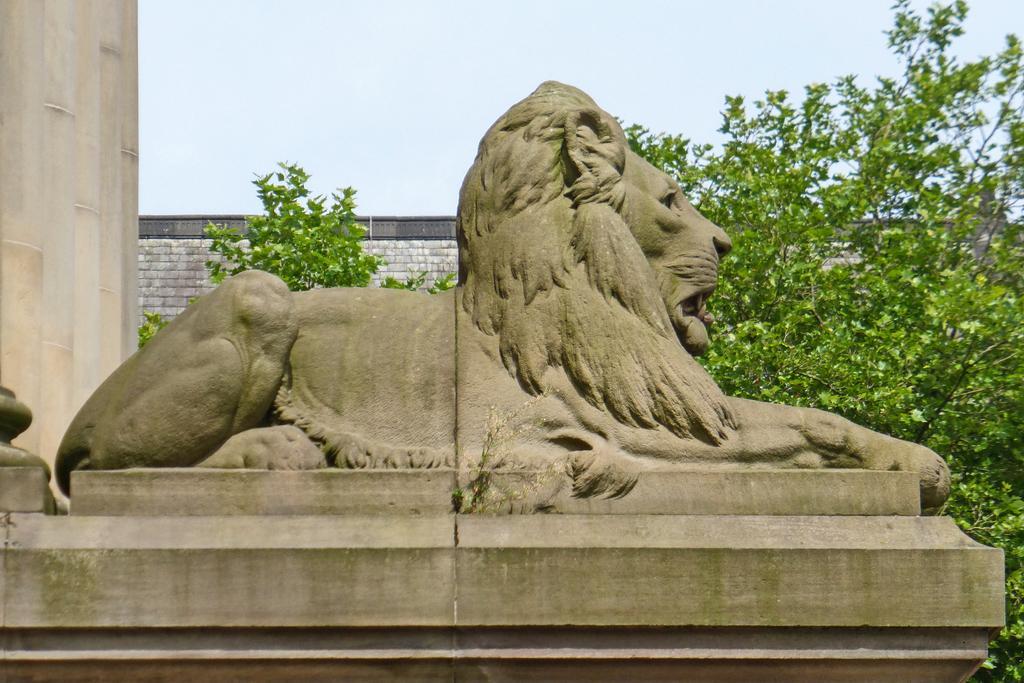Can you describe this image briefly? In this image there is a sculpture of a lion on the wall. Behind it there are plants. In the background there is a wall. At the top there is the sky. To the left there pillars. 